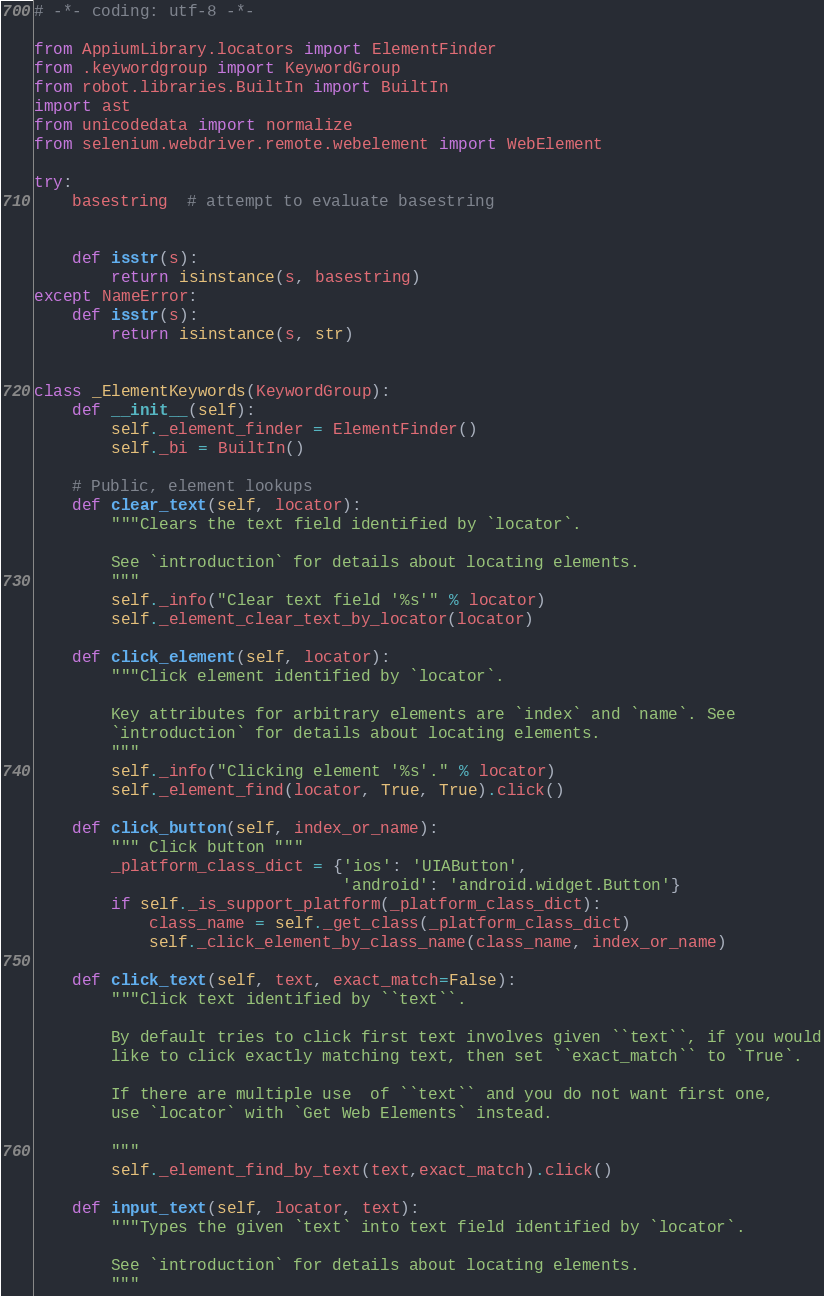Convert code to text. <code><loc_0><loc_0><loc_500><loc_500><_Python_># -*- coding: utf-8 -*-

from AppiumLibrary.locators import ElementFinder
from .keywordgroup import KeywordGroup
from robot.libraries.BuiltIn import BuiltIn
import ast
from unicodedata import normalize
from selenium.webdriver.remote.webelement import WebElement

try:
    basestring  # attempt to evaluate basestring


    def isstr(s):
        return isinstance(s, basestring)
except NameError:
    def isstr(s):
        return isinstance(s, str)


class _ElementKeywords(KeywordGroup):
    def __init__(self):
        self._element_finder = ElementFinder()
        self._bi = BuiltIn()

    # Public, element lookups
    def clear_text(self, locator):
        """Clears the text field identified by `locator`.

        See `introduction` for details about locating elements.
        """
        self._info("Clear text field '%s'" % locator)
        self._element_clear_text_by_locator(locator)

    def click_element(self, locator):
        """Click element identified by `locator`.

        Key attributes for arbitrary elements are `index` and `name`. See
        `introduction` for details about locating elements.
        """
        self._info("Clicking element '%s'." % locator)
        self._element_find(locator, True, True).click()

    def click_button(self, index_or_name):
        """ Click button """
        _platform_class_dict = {'ios': 'UIAButton',
                                'android': 'android.widget.Button'}
        if self._is_support_platform(_platform_class_dict):
            class_name = self._get_class(_platform_class_dict)
            self._click_element_by_class_name(class_name, index_or_name)

    def click_text(self, text, exact_match=False):
        """Click text identified by ``text``.

        By default tries to click first text involves given ``text``, if you would
        like to click exactly matching text, then set ``exact_match`` to `True`.

        If there are multiple use  of ``text`` and you do not want first one,
        use `locator` with `Get Web Elements` instead.

        """
        self._element_find_by_text(text,exact_match).click()

    def input_text(self, locator, text):
        """Types the given `text` into text field identified by `locator`.

        See `introduction` for details about locating elements.
        """</code> 